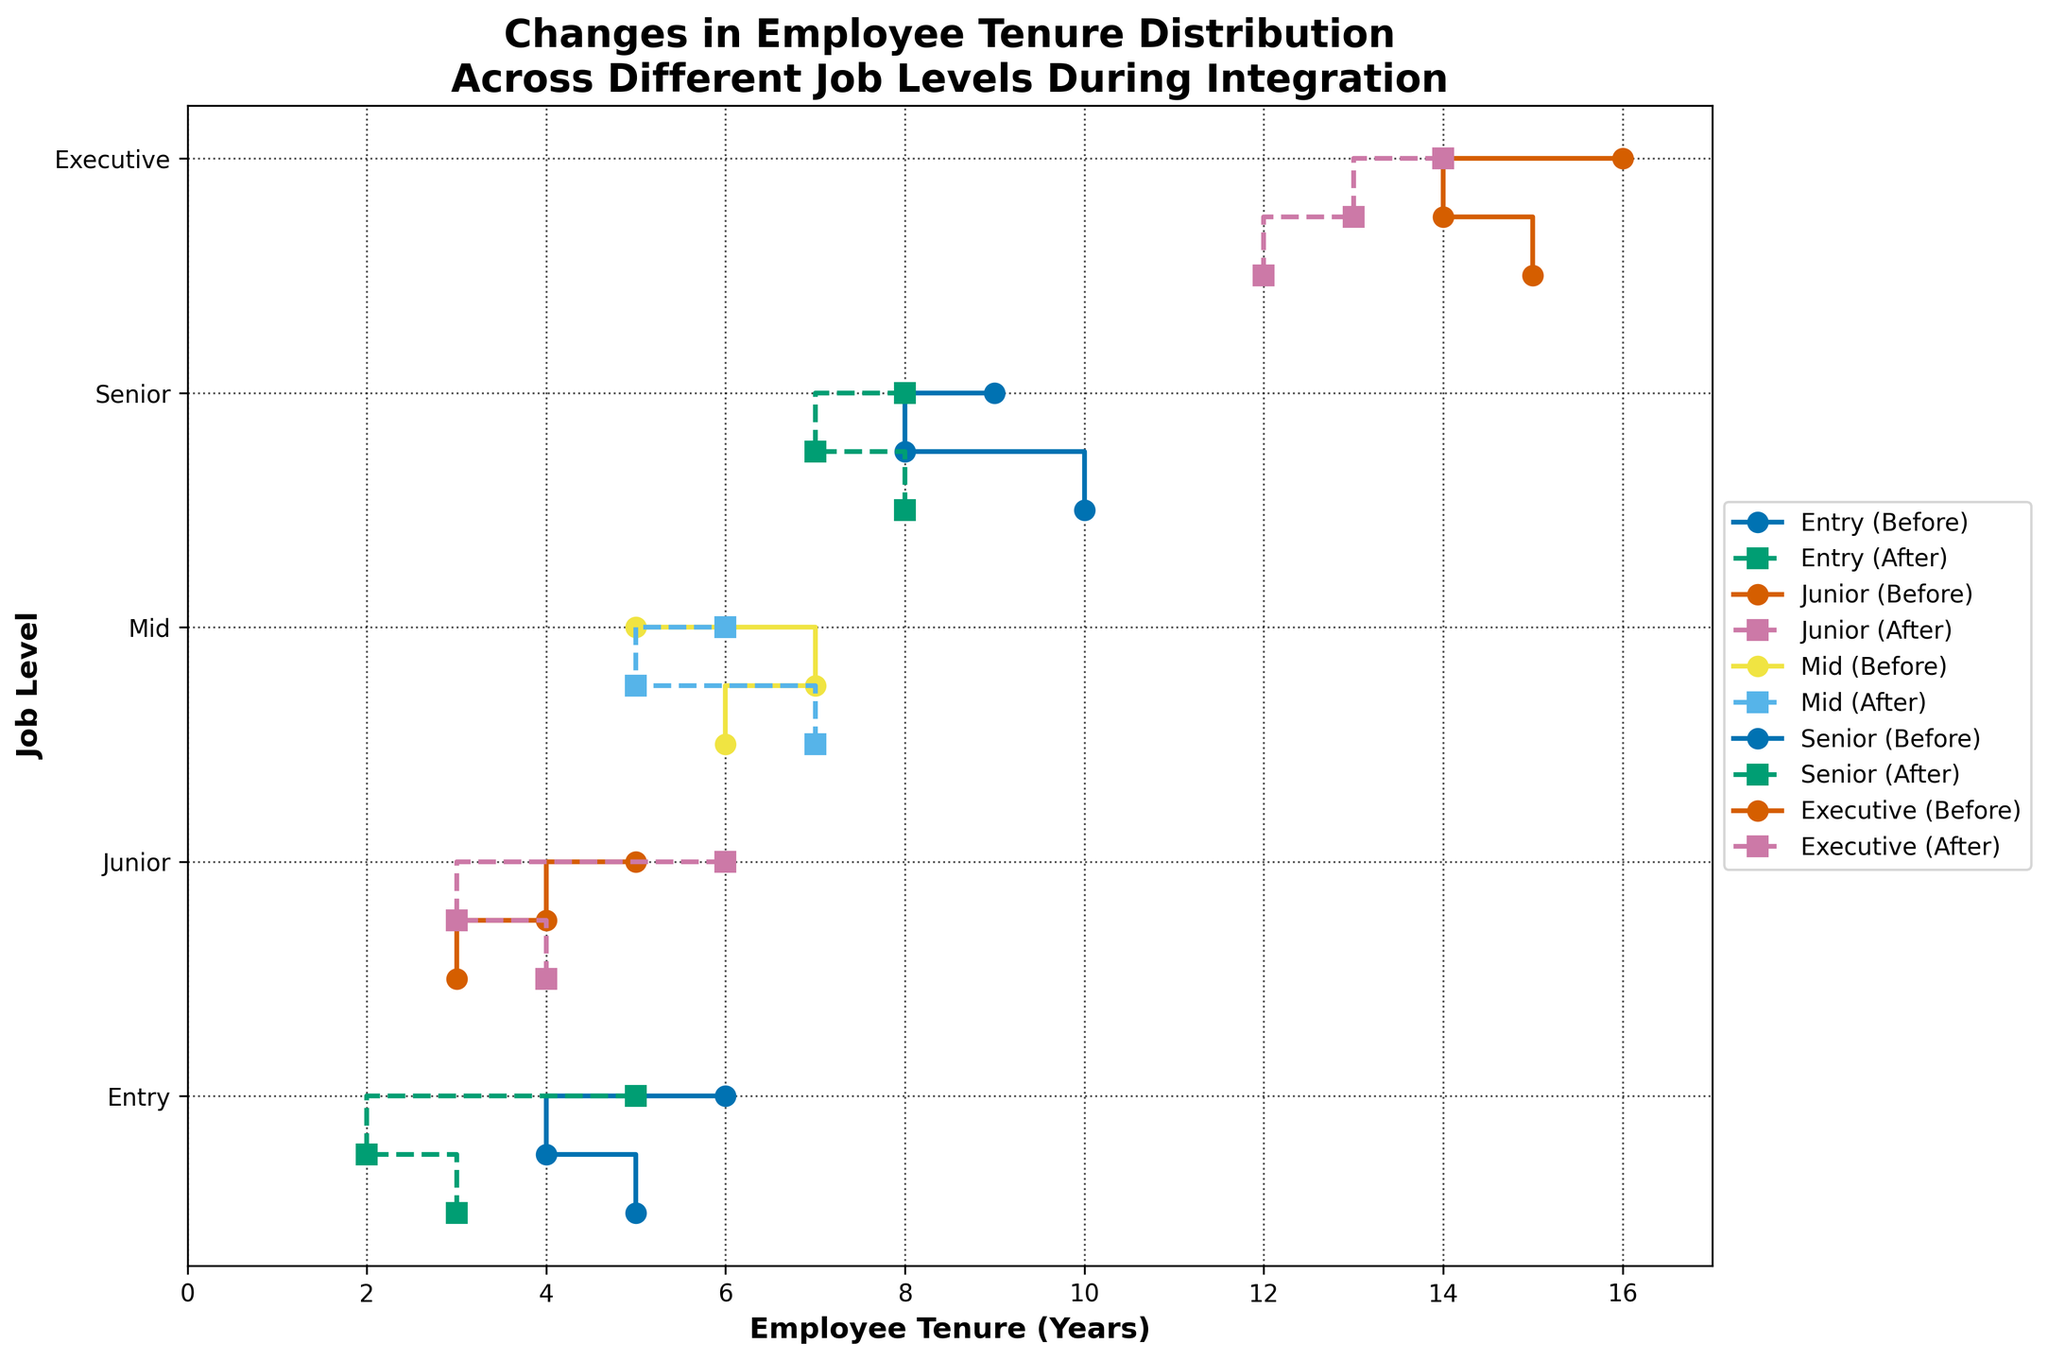What is the title of the figure? The title is usually displayed at the top of the figure. It summarizes the main topic or the focus of the visualization. In this case, it is related to employee tenure distribution across different job levels during integration.
Answer: Changes in Employee Tenure Distribution Across Different Job Levels During Integration Which job level shows a decrease in average employee tenure after integration? To determine this, examine the step lines for each job level. Compare the general trend of 'Before' and 'After' step lines. Look for levels where the 'After' step line is consistently to the left of the 'Before' step line indicating a decrease.
Answer: Entry, Mid, Senior, Executive What is the range of employee tenure for the Junior job level before integration? Identify the step line corresponding to 'Junior (Before)' and count the minimum and maximum values on the x-axis for this level.
Answer: 3 to 5 How much did the average tenure for the 'Executive' job level change after integration? The average tenure can be found by averaging the tenures before and after integration. Calculate the difference between these averages. Before: (15+14+16)/3 = 15; After: (12+13+14)/3 = 13; Change = 15 - 13 = 2.
Answer: 2 For which job level is the difference in average employee tenure before and after integration the greatest? Calculate the difference in average tenure for all job levels and compare them. Entry: 5 - 3.33 = 1.67; Junior: 4 - 4.33 = -0.33; Mid: 6 - 6 = 0; Senior: 9 - 7.67 = 1.33; Executive: 15 - 13 = 2. The maximum difference is for Executive.
Answer: Executive Which job levels have at least one employee with a tenure of 7 years? Identify the step lines that intersect the x-axis at 7 years and check which job levels they belong to, both before and after integration.
Answer: Mid, Senior What is the most significant increase in tenure for 'Mid' job level between 'Before' and 'After' integration? For 'Mid' level employees, compare each pair of 'Before' and 'After' values and find the maximum positive difference. 7-5 = 2, 7-6 = 1, 6-5 = 1. The most significant increase is 2 years.
Answer: 2 How did the tenure for employees at the 'Senior' level change on average after integration? Average the 'Before' and 'After' tenures, then find the difference. Before: (10+8+9)/3 = 9; After: (8+7+8)/3 = 7.67. The change is 9 - 7.67 = 1.33.
Answer: Decreased by 1.33 years Which job level has the same average tenure before and after integration? Compare the average tenure before and after for each job level. Calculation for the Mid level shows that it remains 6 years.
Answer: Mid 